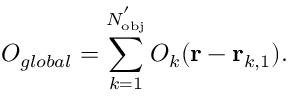<formula> <loc_0><loc_0><loc_500><loc_500>O _ { g l o b a l } = \sum _ { k = 1 } ^ { N _ { o b j } ^ { ^ { \prime } } } O _ { k } ( r - r _ { k , 1 } ) .</formula> 